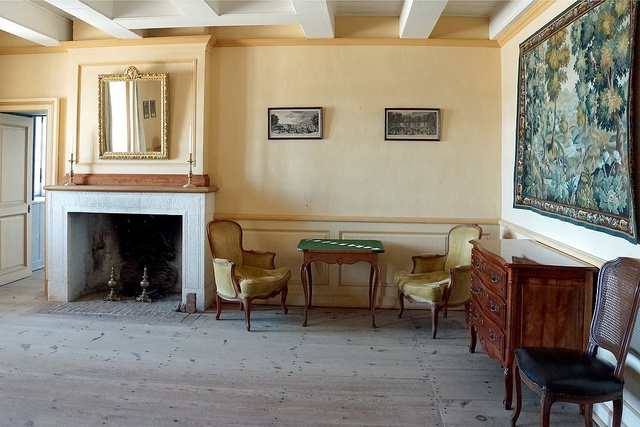Describe the objects in this image and their specific colors. I can see chair in lightgray, black, gray, and darkgray tones, chair in lightgray, maroon, olive, black, and darkgray tones, and chair in lightgray, maroon, olive, black, and tan tones in this image. 